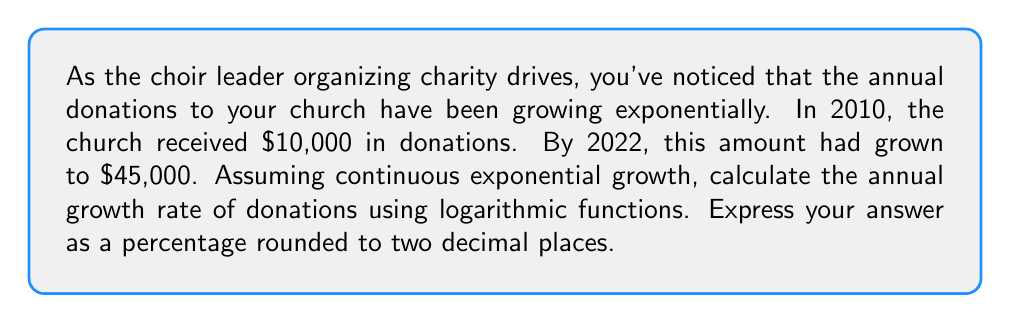Teach me how to tackle this problem. To solve this problem, we'll use the continuous exponential growth formula:

$$A = P \cdot e^{rt}$$

Where:
$A$ = Final amount ($45,000)
$P$ = Initial amount ($10,000)
$e$ = Euler's number (approximately 2.71828)
$r$ = Annual growth rate (what we're solving for)
$t$ = Time in years (2022 - 2010 = 12 years)

Let's substitute these values into the equation:

$$45000 = 10000 \cdot e^{12r}$$

To solve for $r$, we'll use logarithms. First, divide both sides by 10000:

$$4.5 = e^{12r}$$

Now, take the natural logarithm of both sides:

$$\ln(4.5) = \ln(e^{12r})$$

Using the logarithm property $\ln(e^x) = x$, we get:

$$\ln(4.5) = 12r$$

Solve for $r$:

$$r = \frac{\ln(4.5)}{12}$$

Calculate this value:

$$r = \frac{1.5040773967762742}{12} \approx 0.1253397830646895$$

To convert to a percentage, multiply by 100:

$$0.1253397830646895 \cdot 100 \approx 12.53\%$$
Answer: The annual growth rate of donations is approximately 12.53%. 